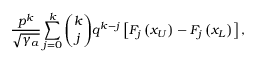Convert formula to latex. <formula><loc_0><loc_0><loc_500><loc_500>\frac { p ^ { k } } { \sqrt { \gamma _ { a } } } \sum _ { j = 0 } ^ { k } { \binom { k } { j } } q ^ { k - j } \left [ F _ { j } \left ( x _ { U } \right ) - F _ { j } \left ( x _ { L } \right ) \right ] ,</formula> 